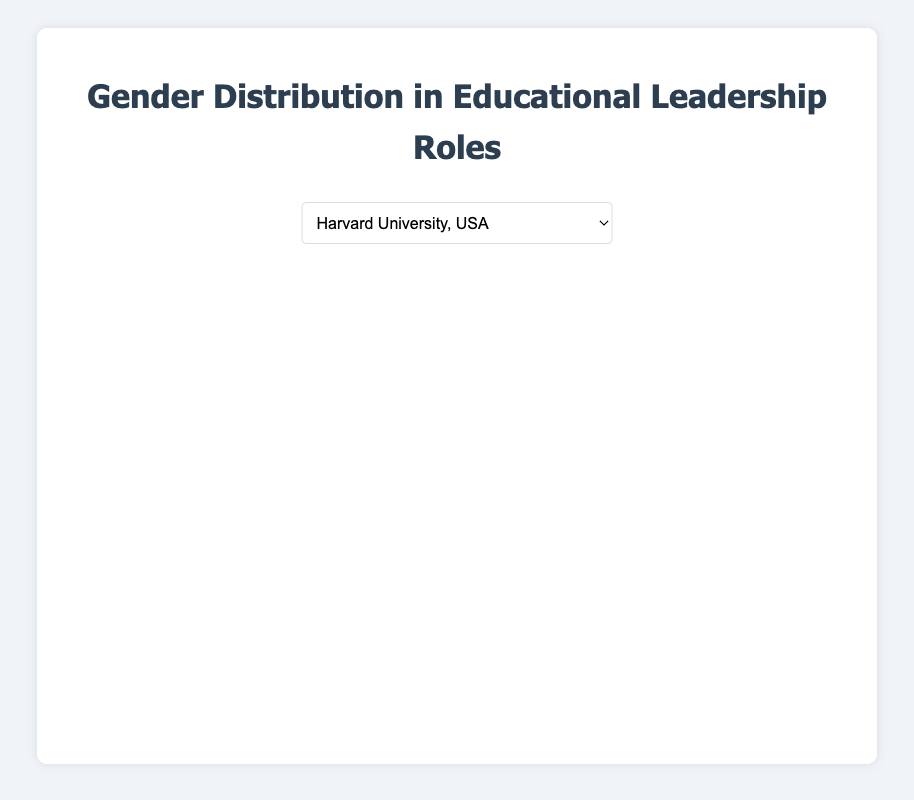What is the percentage of females in educational leadership roles at the University of Helsinki? The pie chart for the University of Helsinki shows the gender distribution in leadership roles. The percentage of females is calculated by dividing the number of females by the total number of roles and then multiplying by 100. Female roles are 50, the total roles are 50+45+5 = 100. So, (50/100) * 100% = 50%
Answer: 50% What is the difference in the number of male leadership roles between the University of Tokyo and Harvard University? The pie chart for the University of Tokyo shows 60 males, and for Harvard University, it shows 50 males. The difference is calculated by subtracting the number of roles at Harvard from those at Tokyo, 60 - 50 = 10.
Answer: 10 How many non-binary leadership roles are there at the University of Cape Town as a percentage of the total? The pie chart for the University of Cape Town shows 5 non-binary leadership roles. The total number of roles is the sum of all gender roles: 40 (Female) + 55 (Male) + 5 (Non-binary) = 100. The percentage is (5/100) * 100% = 5%
Answer: 5% Which institution has the highest number of female leadership roles? The pie charts show the number of female leadership roles across institutions. The University of Melbourne has the highest at 55.
Answer: University of Melbourne What is the combined total of leadership roles for non-binary individuals across all five institutions? Adding up the non-binary roles from the pie charts: Harvard: 5, Tokyo: 5, Cape Town: 5, Helsinki: 5, Melbourne: 5. Total = 5 + 5 + 5 + 5 + 5 = 25.
Answer: 25 Compare the percentages of male and female leadership roles at the University of Tokyo. Which is higher? At the University of Tokyo, the pie chart shows 35 females and 60 males. The total roles are 35+60+5 = 100. The percentage for females is (35/100) * 100% = 35% and for males is (60/100) * 100% = 60%. Thus, the percentage of male roles is higher.
Answer: Male What is the percentage of educational leadership roles held by non-binary individuals at Harvard University? Harvard University has 5 non-binary roles. The total number of roles is 45 (Female) + 50 (Male) + 5 (Non-binary) = 100. The percentage is (5/100) * 100% = 5%
Answer: 5% If you sum the percentage of female leadership roles at Harvard University and the University of Helsinki, what do you get? The pie charts show that Harvard University has 45% female leadership roles and the University of Helsinki has 50%. Summing these percentages: 45% + 50% = 95%.
Answer: 95% How does the distribution of leadership roles at the University of Melbourne visually compare to that of the University of Cape Town? In the pie charts, the University of Melbourne has a larger red section (female) at 55 compared to Cape Town's 40. Both have the same yellow section (non-binary) at 5. The blue section (male) is smaller at Melbourne with 40 compared to Cape Town’s 55. Therefore, Melbourne has more females and fewer males visually.
Answer: Melbourne has more females and fewer males 